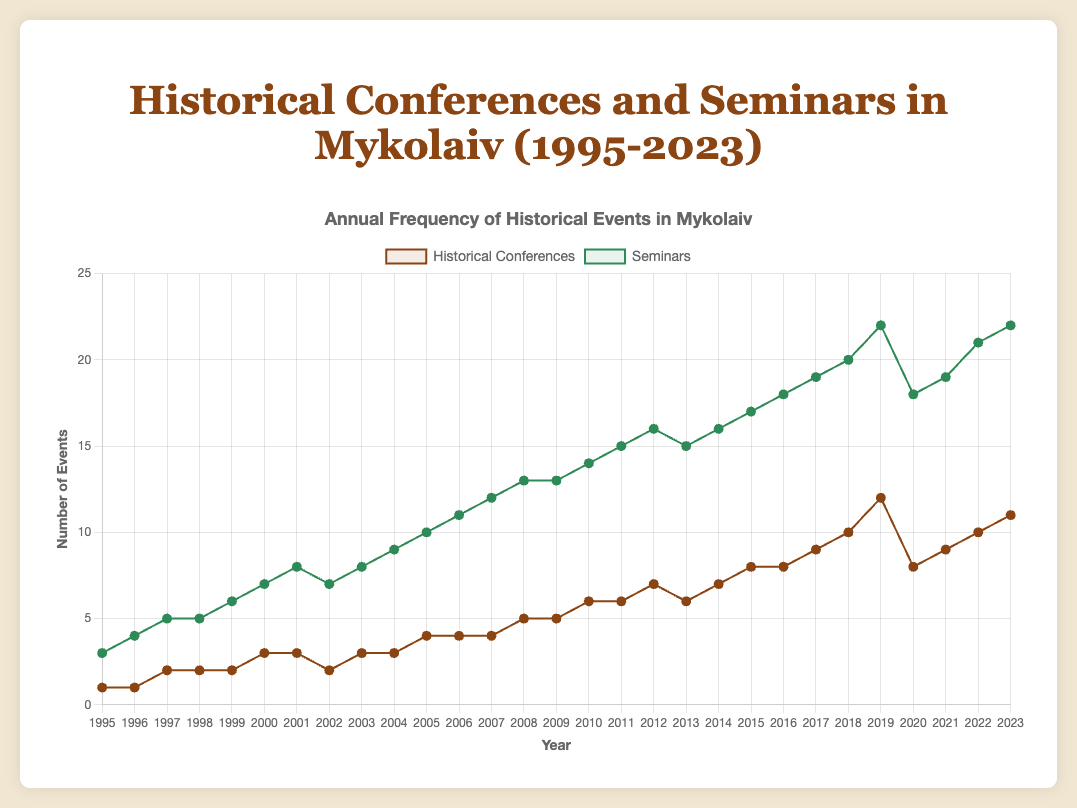What is the total number of historical conferences hosted between 1995 and 2000? The data for historical conferences from 1995 to 2000 is [1, 1, 2, 2, 2, 3]. Summing these values: 1 + 1 + 2 + 2 + 2 + 3 = 11
Answer: 11 In what year did the number of seminars first reach 15? By observing the seminar data, the first year when the number of seminars reaches 15 is 2011.
Answer: 2011 Which event type had a higher count in the year 2018, historical conferences or seminars? In 2018, the number of historical conferences was 10 and the number of seminars was 20. Since 20 is greater than 10, seminars had a higher count.
Answer: seminars How many more seminars were held in 2023 compared to 2003? The number of seminars in 2023 was 22, while in 2003 it was 8. The difference is 22 - 8 = 14.
Answer: 14 What is the difference between the highest number of seminars and the highest number of historical conferences across all years? The highest number of seminars is 22, and the highest number of historical conferences is 12. The difference is 22 - 12 = 10.
Answer: 10 Did the number of historical conferences or seminars show a more significant increase from 1995 to 2023? The number of historical conferences in 1995 was 1 and increased to 11 by 2023, a difference of 10. For seminars, the number went from 3 in 1995 to 22 in 2023, a difference of 19. Thus, seminars showed a more significant increase.
Answer: seminars Between which consecutive years was the largest increase in the number of historical conferences observed? The largest increase in historical conferences was between 2018 (10 conferences) and 2019 (12 conferences), an increase of 2.
Answer: 2018 to 2019 What was the number of seminars in the year 2006? By referring to the data, the number of seminars in 2006 was 11.
Answer: 11 How many years had more than 15 seminars? By checking the data, the years with more than 15 seminars are 2011, 2012, 2014, 2015, 2016, 2017, 2018, 2019, 2021, 2022, and 2023. There are 11 such years.
Answer: 11 How did the number of historical conferences change from 2007 to 2008? The number of historical conferences in 2007 was 4 and it increased to 5 in 2008. Therefore, there was an increase by 1.
Answer: increased by 1 